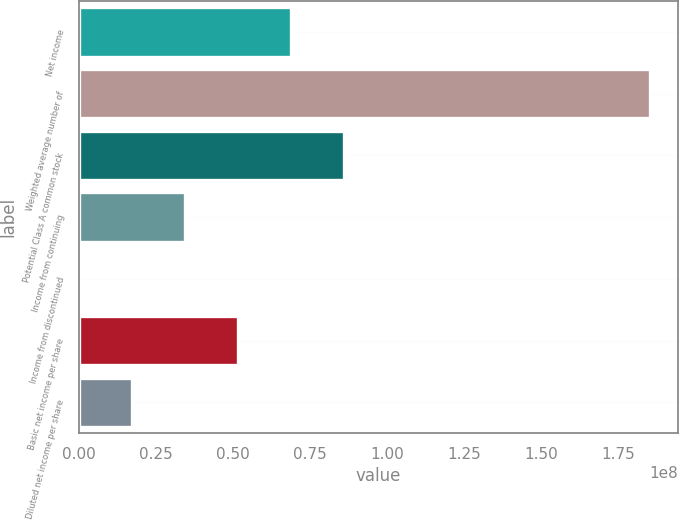<chart> <loc_0><loc_0><loc_500><loc_500><bar_chart><fcel>Net income<fcel>Weighted average number of<fcel>Potential Class A common stock<fcel>Income from continuing<fcel>Income from discontinued<fcel>Basic net income per share<fcel>Diluted net income per share<nl><fcel>6.89105e+07<fcel>1.85259e+08<fcel>8.61382e+07<fcel>3.44553e+07<fcel>0.03<fcel>5.16829e+07<fcel>1.72276e+07<nl></chart> 